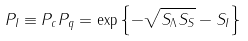Convert formula to latex. <formula><loc_0><loc_0><loc_500><loc_500>P _ { I } \equiv P _ { c } P _ { q } = \exp { \left \{ - \sqrt { S _ { \Lambda } S _ { S } } - S _ { I } \right \} }</formula> 